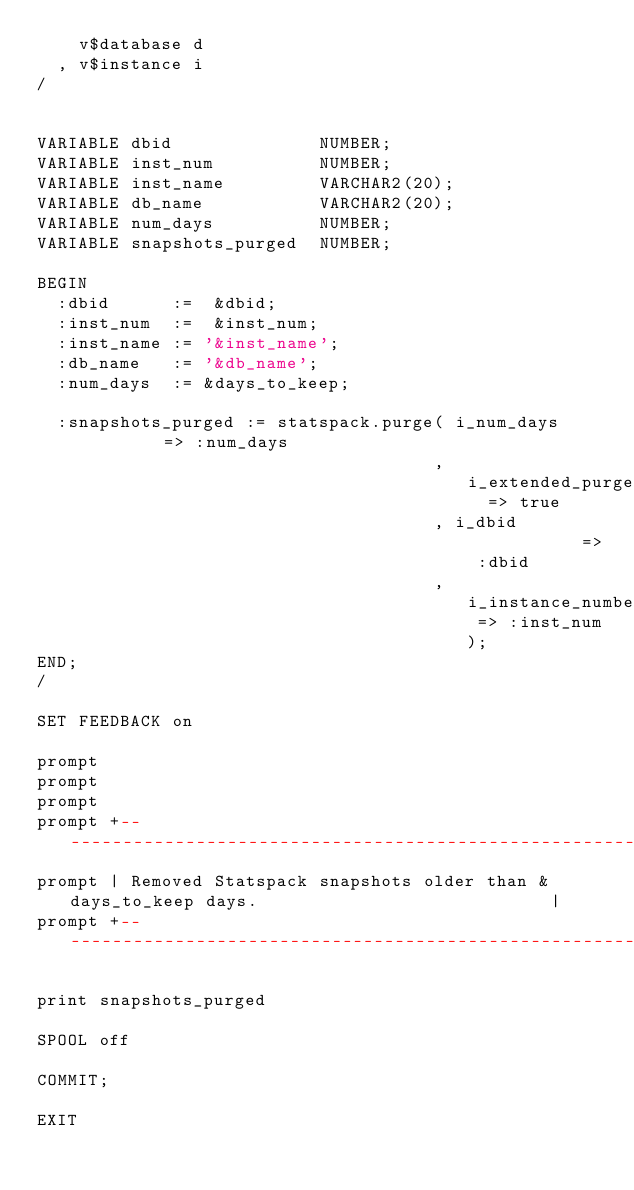<code> <loc_0><loc_0><loc_500><loc_500><_SQL_>    v$database d
  , v$instance i
/


VARIABLE dbid              NUMBER;
VARIABLE inst_num          NUMBER;
VARIABLE inst_name         VARCHAR2(20);
VARIABLE db_name           VARCHAR2(20);
VARIABLE num_days          NUMBER;
VARIABLE snapshots_purged  NUMBER;

BEGIN
  :dbid      :=  &dbid;
  :inst_num  :=  &inst_num;
  :inst_name := '&inst_name';
  :db_name   := '&db_name';
  :num_days  := &days_to_keep;

  :snapshots_purged := statspack.purge( i_num_days        => :num_days
                                      , i_extended_purge  => true
                                      , i_dbid            => :dbid
                                      , i_instance_number => :inst_num);
END;
/

SET FEEDBACK on

prompt 
prompt 
prompt 
prompt +----------------------------------------------------------------------------+
prompt | Removed Statspack snapshots older than &days_to_keep days.                            |
prompt +----------------------------------------------------------------------------+

print snapshots_purged

SPOOL off

COMMIT;

EXIT

</code> 